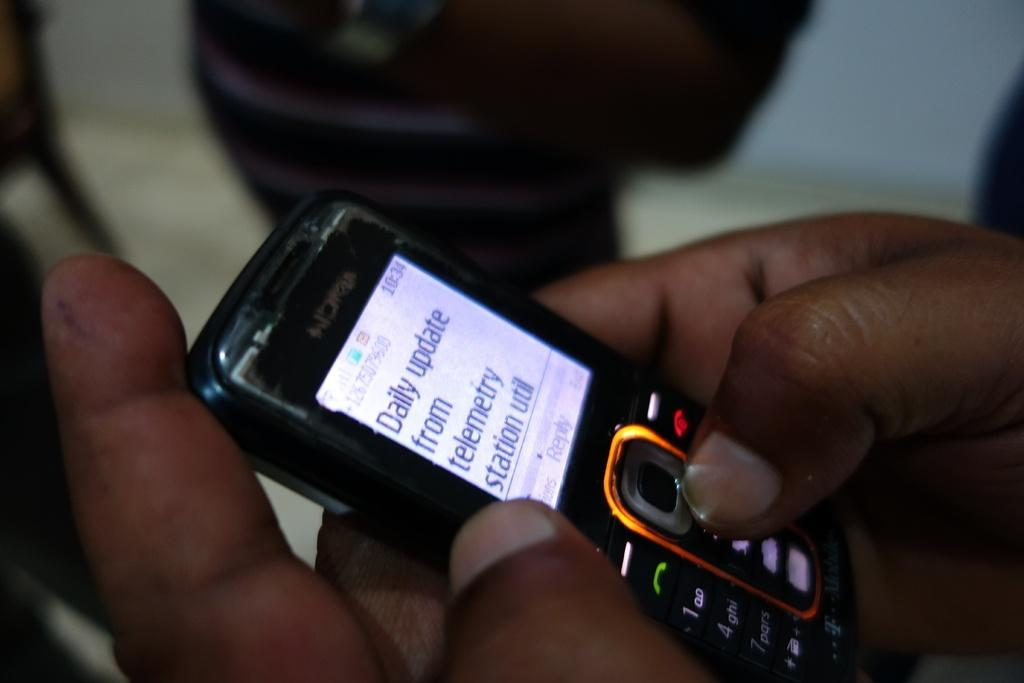<image>
Share a concise interpretation of the image provided. A cell phone with a daily update on it 